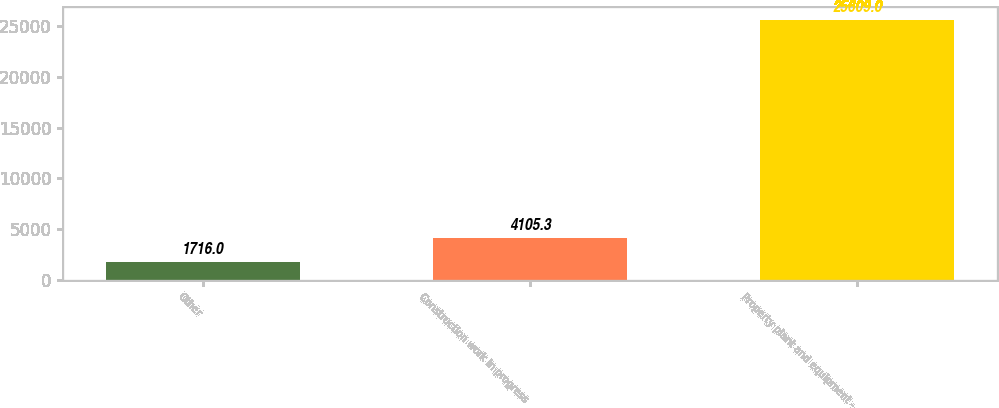<chart> <loc_0><loc_0><loc_500><loc_500><bar_chart><fcel>Other<fcel>Construction work in progress<fcel>Property plant and equipment -<nl><fcel>1716<fcel>4105.3<fcel>25609<nl></chart> 